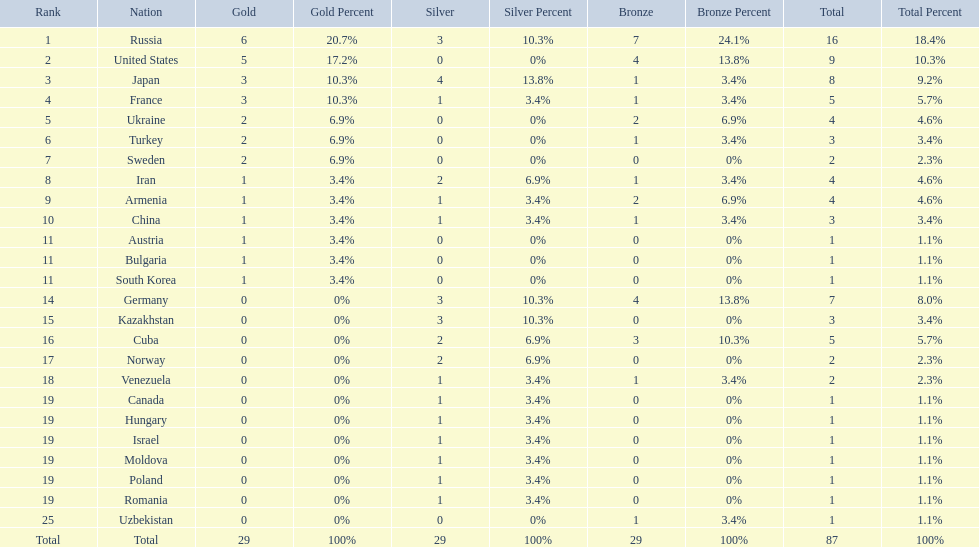What nations have one gold medal? Iran, Armenia, China, Austria, Bulgaria, South Korea. Of these, which nations have zero silver medals? Austria, Bulgaria, South Korea. Of these, which nations also have zero bronze medals? Austria. 